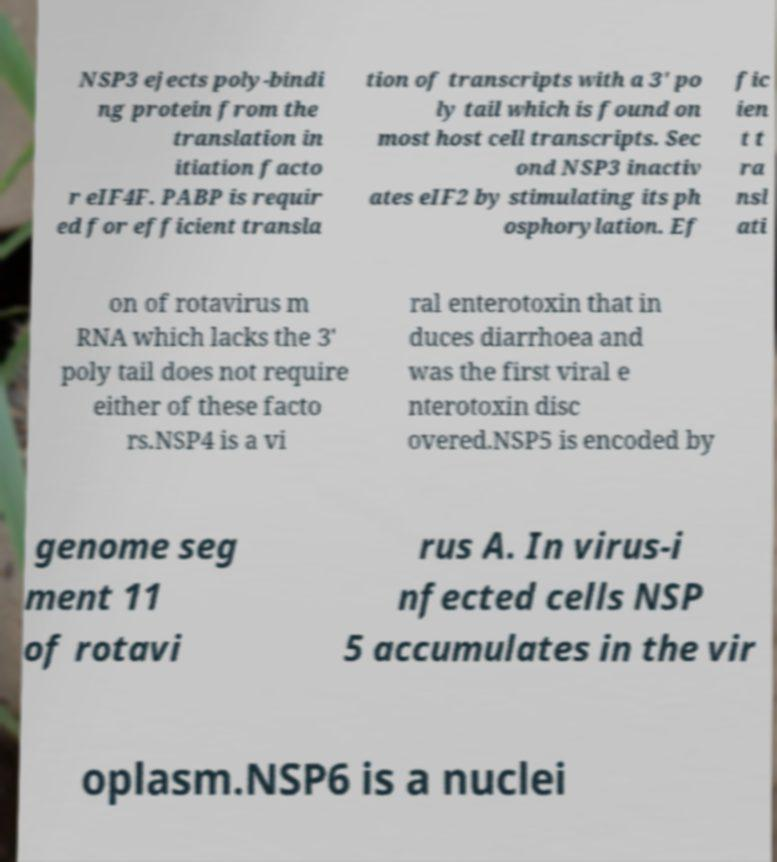Could you extract and type out the text from this image? NSP3 ejects poly-bindi ng protein from the translation in itiation facto r eIF4F. PABP is requir ed for efficient transla tion of transcripts with a 3' po ly tail which is found on most host cell transcripts. Sec ond NSP3 inactiv ates eIF2 by stimulating its ph osphorylation. Ef fic ien t t ra nsl ati on of rotavirus m RNA which lacks the 3' poly tail does not require either of these facto rs.NSP4 is a vi ral enterotoxin that in duces diarrhoea and was the first viral e nterotoxin disc overed.NSP5 is encoded by genome seg ment 11 of rotavi rus A. In virus-i nfected cells NSP 5 accumulates in the vir oplasm.NSP6 is a nuclei 